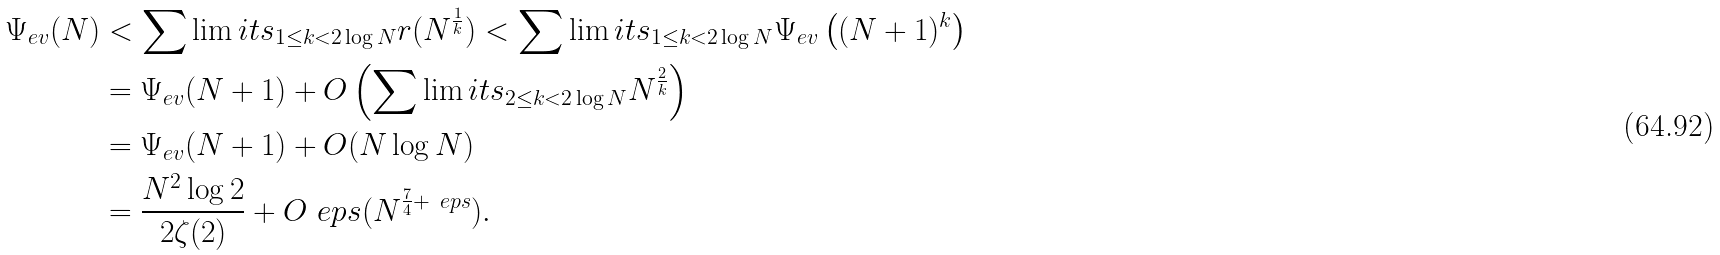Convert formula to latex. <formula><loc_0><loc_0><loc_500><loc_500>\Psi _ { e v } ( N ) & < \sum \lim i t s _ { 1 \leq k < 2 \log N } r ( N ^ { \frac { 1 } { k } } ) < \sum \lim i t s _ { 1 \leq k < 2 \log N } \Psi _ { e v } \left ( ( N + 1 ) ^ { k } \right ) \\ & = \Psi _ { e v } ( N + 1 ) + O \left ( \sum \lim i t s _ { 2 \leq k < 2 \log N } N ^ { \frac { 2 } { k } } \right ) \\ & = \Psi _ { e v } ( N + 1 ) + O ( N \log N ) \\ & = \frac { N ^ { 2 } \log 2 } { 2 \zeta ( 2 ) } + O _ { \ } e p s ( N ^ { \frac { 7 } { 4 } + \ e p s } ) .</formula> 